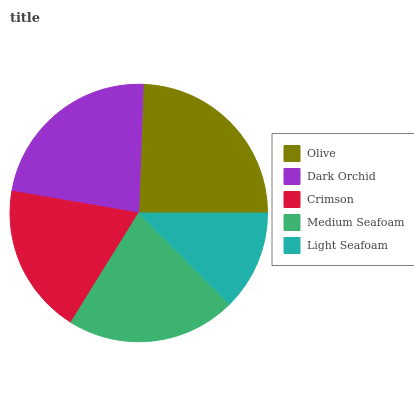Is Light Seafoam the minimum?
Answer yes or no. Yes. Is Olive the maximum?
Answer yes or no. Yes. Is Dark Orchid the minimum?
Answer yes or no. No. Is Dark Orchid the maximum?
Answer yes or no. No. Is Olive greater than Dark Orchid?
Answer yes or no. Yes. Is Dark Orchid less than Olive?
Answer yes or no. Yes. Is Dark Orchid greater than Olive?
Answer yes or no. No. Is Olive less than Dark Orchid?
Answer yes or no. No. Is Medium Seafoam the high median?
Answer yes or no. Yes. Is Medium Seafoam the low median?
Answer yes or no. Yes. Is Light Seafoam the high median?
Answer yes or no. No. Is Light Seafoam the low median?
Answer yes or no. No. 